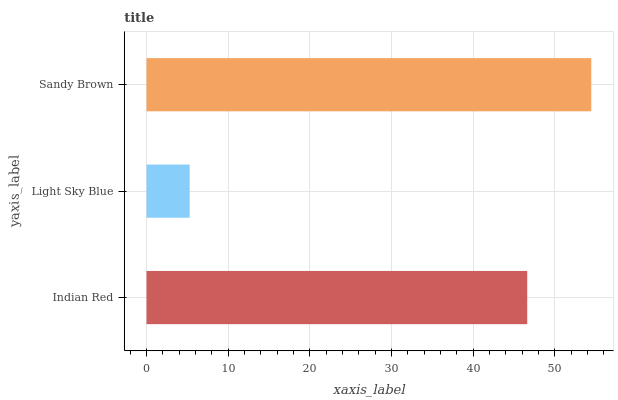Is Light Sky Blue the minimum?
Answer yes or no. Yes. Is Sandy Brown the maximum?
Answer yes or no. Yes. Is Sandy Brown the minimum?
Answer yes or no. No. Is Light Sky Blue the maximum?
Answer yes or no. No. Is Sandy Brown greater than Light Sky Blue?
Answer yes or no. Yes. Is Light Sky Blue less than Sandy Brown?
Answer yes or no. Yes. Is Light Sky Blue greater than Sandy Brown?
Answer yes or no. No. Is Sandy Brown less than Light Sky Blue?
Answer yes or no. No. Is Indian Red the high median?
Answer yes or no. Yes. Is Indian Red the low median?
Answer yes or no. Yes. Is Light Sky Blue the high median?
Answer yes or no. No. Is Light Sky Blue the low median?
Answer yes or no. No. 